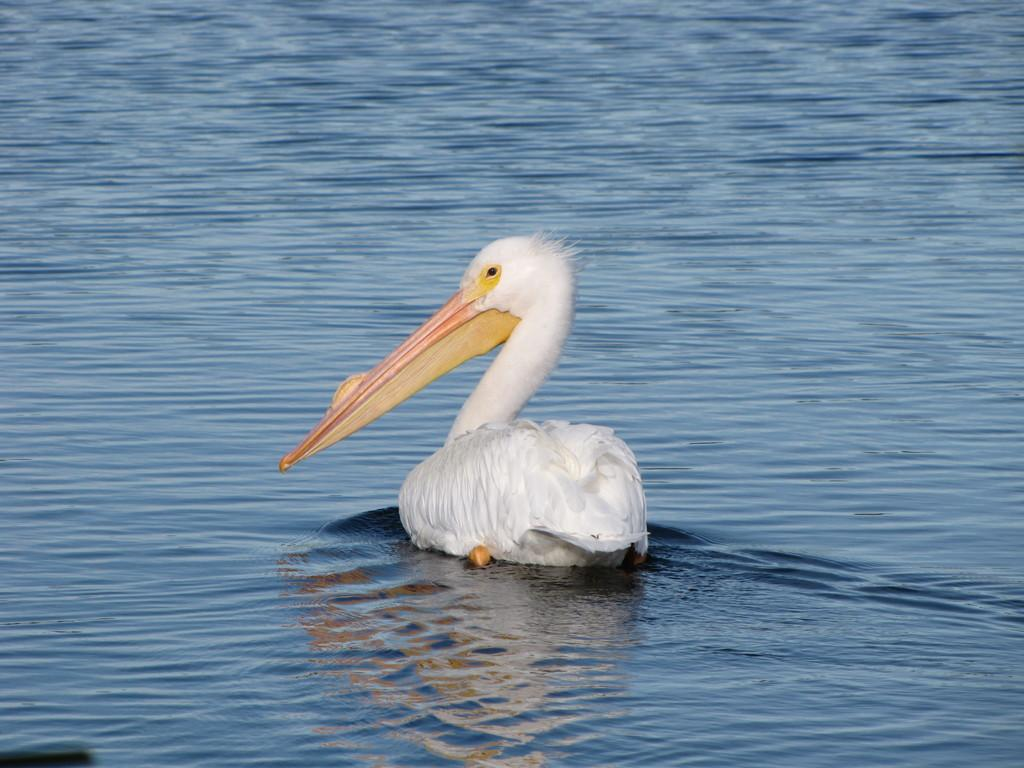What type of animal is present in the image? There is a bird in the image. Where is the bird located in the image? The bird is on the water. What type of offer is the bird making to the pizzas in the image? There are no pizzas present in the image, and therefore no such offer can be observed. 